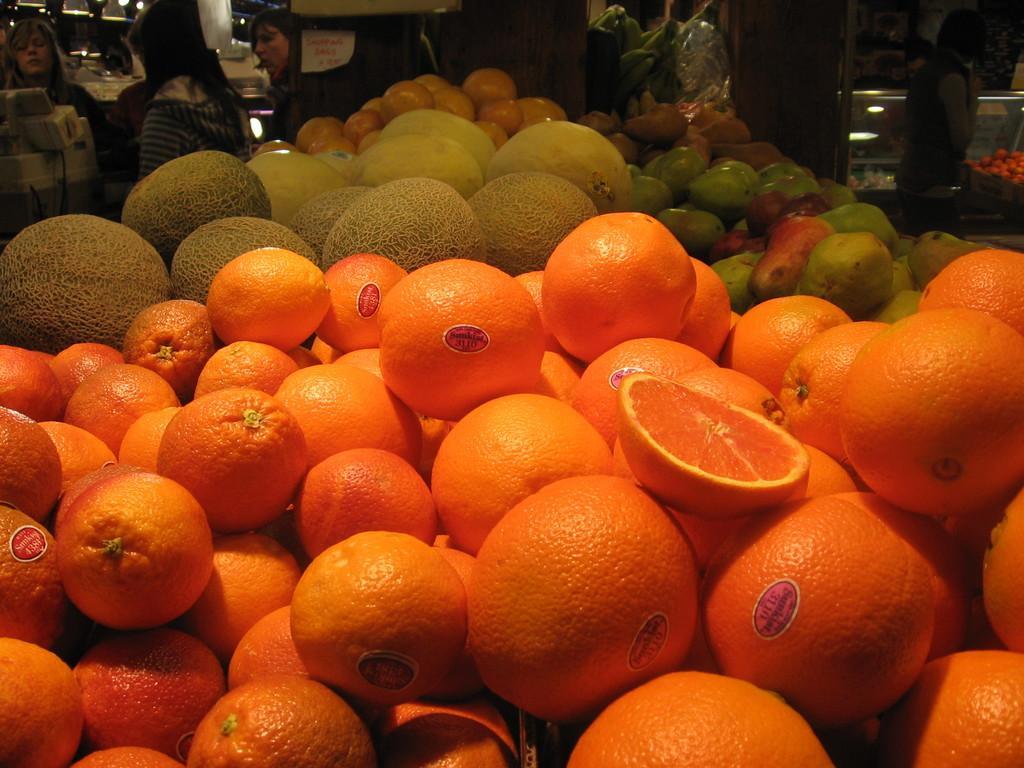Describe this image in one or two sentences. In the center of the image we can see different types of fruits and vegetables like oranges, tomatoes, potatoes etc. In the background there is a wall, one machine, lights, notes, baskets, glass, vegetables, few people are standing and few other objects. 